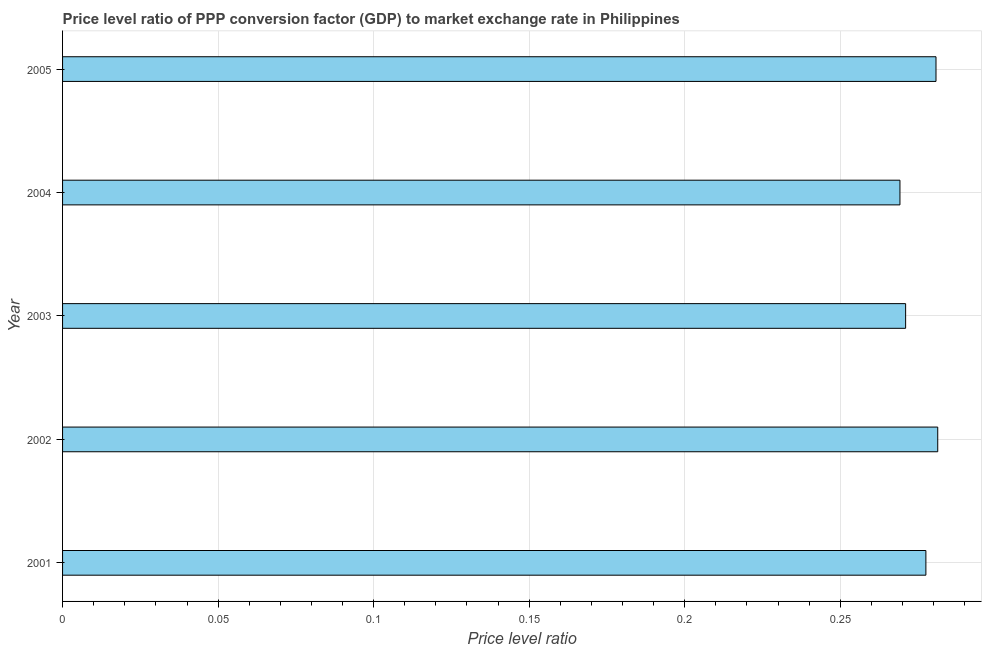What is the title of the graph?
Provide a succinct answer. Price level ratio of PPP conversion factor (GDP) to market exchange rate in Philippines. What is the label or title of the X-axis?
Make the answer very short. Price level ratio. What is the label or title of the Y-axis?
Give a very brief answer. Year. What is the price level ratio in 2004?
Keep it short and to the point. 0.27. Across all years, what is the maximum price level ratio?
Your answer should be very brief. 0.28. Across all years, what is the minimum price level ratio?
Provide a succinct answer. 0.27. What is the sum of the price level ratio?
Ensure brevity in your answer.  1.38. What is the difference between the price level ratio in 2002 and 2005?
Your response must be concise. 0. What is the average price level ratio per year?
Offer a terse response. 0.28. What is the median price level ratio?
Provide a short and direct response. 0.28. In how many years, is the price level ratio greater than 0.28 ?
Your answer should be very brief. 2. Do a majority of the years between 2002 and 2001 (inclusive) have price level ratio greater than 0.21 ?
Your response must be concise. No. What is the ratio of the price level ratio in 2001 to that in 2005?
Ensure brevity in your answer.  0.99. Is the price level ratio in 2001 less than that in 2005?
Your response must be concise. Yes. Is the difference between the price level ratio in 2002 and 2004 greater than the difference between any two years?
Offer a very short reply. Yes. Is the sum of the price level ratio in 2002 and 2004 greater than the maximum price level ratio across all years?
Ensure brevity in your answer.  Yes. In how many years, is the price level ratio greater than the average price level ratio taken over all years?
Your response must be concise. 3. How many bars are there?
Your answer should be compact. 5. Are the values on the major ticks of X-axis written in scientific E-notation?
Keep it short and to the point. No. What is the Price level ratio of 2001?
Ensure brevity in your answer.  0.28. What is the Price level ratio in 2002?
Provide a succinct answer. 0.28. What is the Price level ratio in 2003?
Provide a succinct answer. 0.27. What is the Price level ratio in 2004?
Ensure brevity in your answer.  0.27. What is the Price level ratio of 2005?
Provide a short and direct response. 0.28. What is the difference between the Price level ratio in 2001 and 2002?
Keep it short and to the point. -0. What is the difference between the Price level ratio in 2001 and 2003?
Provide a succinct answer. 0.01. What is the difference between the Price level ratio in 2001 and 2004?
Provide a succinct answer. 0.01. What is the difference between the Price level ratio in 2001 and 2005?
Your answer should be compact. -0. What is the difference between the Price level ratio in 2002 and 2003?
Ensure brevity in your answer.  0.01. What is the difference between the Price level ratio in 2002 and 2004?
Your answer should be very brief. 0.01. What is the difference between the Price level ratio in 2002 and 2005?
Give a very brief answer. 0. What is the difference between the Price level ratio in 2003 and 2004?
Offer a very short reply. 0. What is the difference between the Price level ratio in 2003 and 2005?
Your response must be concise. -0.01. What is the difference between the Price level ratio in 2004 and 2005?
Your answer should be very brief. -0.01. What is the ratio of the Price level ratio in 2001 to that in 2002?
Your response must be concise. 0.99. What is the ratio of the Price level ratio in 2001 to that in 2004?
Make the answer very short. 1.03. What is the ratio of the Price level ratio in 2002 to that in 2003?
Ensure brevity in your answer.  1.04. What is the ratio of the Price level ratio in 2002 to that in 2004?
Your answer should be very brief. 1.04. What is the ratio of the Price level ratio in 2002 to that in 2005?
Keep it short and to the point. 1. 